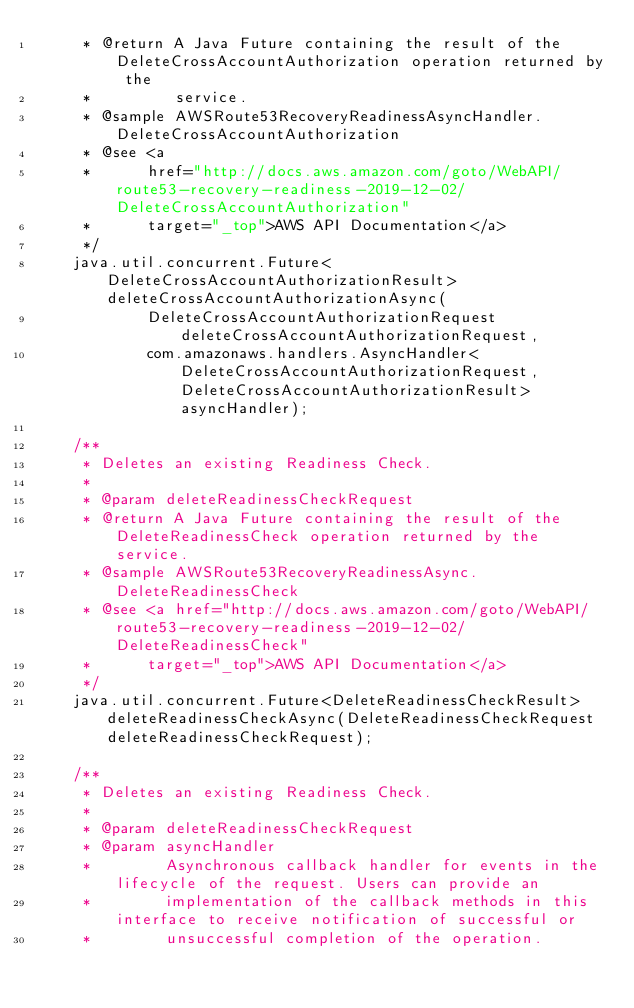<code> <loc_0><loc_0><loc_500><loc_500><_Java_>     * @return A Java Future containing the result of the DeleteCrossAccountAuthorization operation returned by the
     *         service.
     * @sample AWSRoute53RecoveryReadinessAsyncHandler.DeleteCrossAccountAuthorization
     * @see <a
     *      href="http://docs.aws.amazon.com/goto/WebAPI/route53-recovery-readiness-2019-12-02/DeleteCrossAccountAuthorization"
     *      target="_top">AWS API Documentation</a>
     */
    java.util.concurrent.Future<DeleteCrossAccountAuthorizationResult> deleteCrossAccountAuthorizationAsync(
            DeleteCrossAccountAuthorizationRequest deleteCrossAccountAuthorizationRequest,
            com.amazonaws.handlers.AsyncHandler<DeleteCrossAccountAuthorizationRequest, DeleteCrossAccountAuthorizationResult> asyncHandler);

    /**
     * Deletes an existing Readiness Check.
     * 
     * @param deleteReadinessCheckRequest
     * @return A Java Future containing the result of the DeleteReadinessCheck operation returned by the service.
     * @sample AWSRoute53RecoveryReadinessAsync.DeleteReadinessCheck
     * @see <a href="http://docs.aws.amazon.com/goto/WebAPI/route53-recovery-readiness-2019-12-02/DeleteReadinessCheck"
     *      target="_top">AWS API Documentation</a>
     */
    java.util.concurrent.Future<DeleteReadinessCheckResult> deleteReadinessCheckAsync(DeleteReadinessCheckRequest deleteReadinessCheckRequest);

    /**
     * Deletes an existing Readiness Check.
     * 
     * @param deleteReadinessCheckRequest
     * @param asyncHandler
     *        Asynchronous callback handler for events in the lifecycle of the request. Users can provide an
     *        implementation of the callback methods in this interface to receive notification of successful or
     *        unsuccessful completion of the operation.</code> 